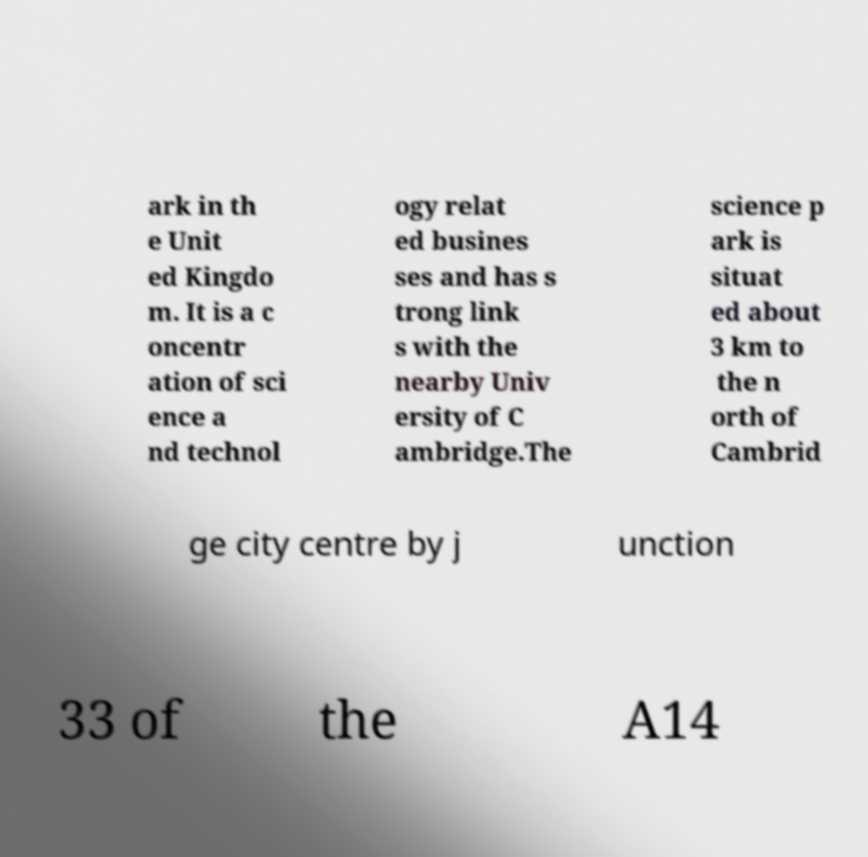There's text embedded in this image that I need extracted. Can you transcribe it verbatim? ark in th e Unit ed Kingdo m. It is a c oncentr ation of sci ence a nd technol ogy relat ed busines ses and has s trong link s with the nearby Univ ersity of C ambridge.The science p ark is situat ed about 3 km to the n orth of Cambrid ge city centre by j unction 33 of the A14 